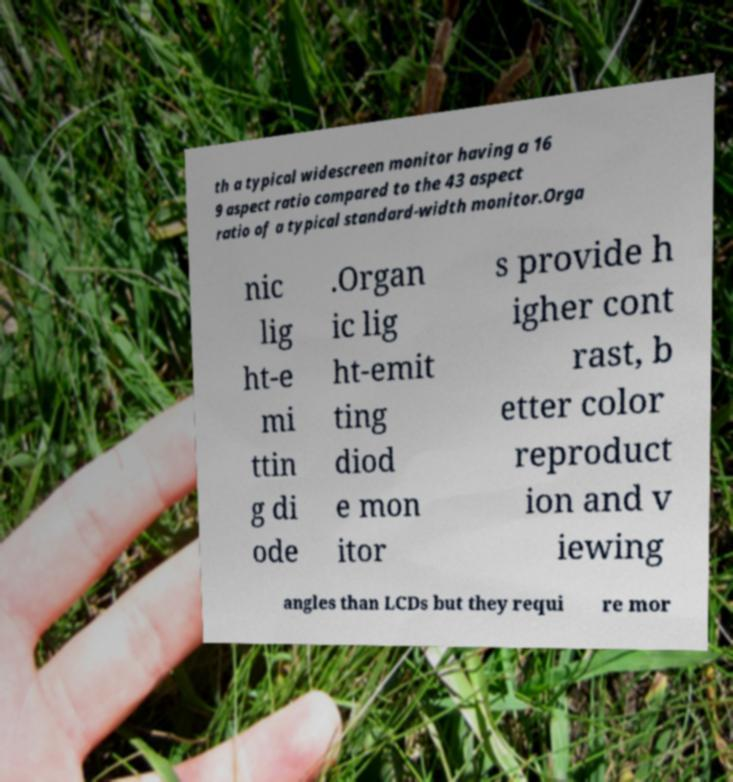Please read and relay the text visible in this image. What does it say? th a typical widescreen monitor having a 16 9 aspect ratio compared to the 43 aspect ratio of a typical standard-width monitor.Orga nic lig ht-e mi ttin g di ode .Organ ic lig ht-emit ting diod e mon itor s provide h igher cont rast, b etter color reproduct ion and v iewing angles than LCDs but they requi re mor 